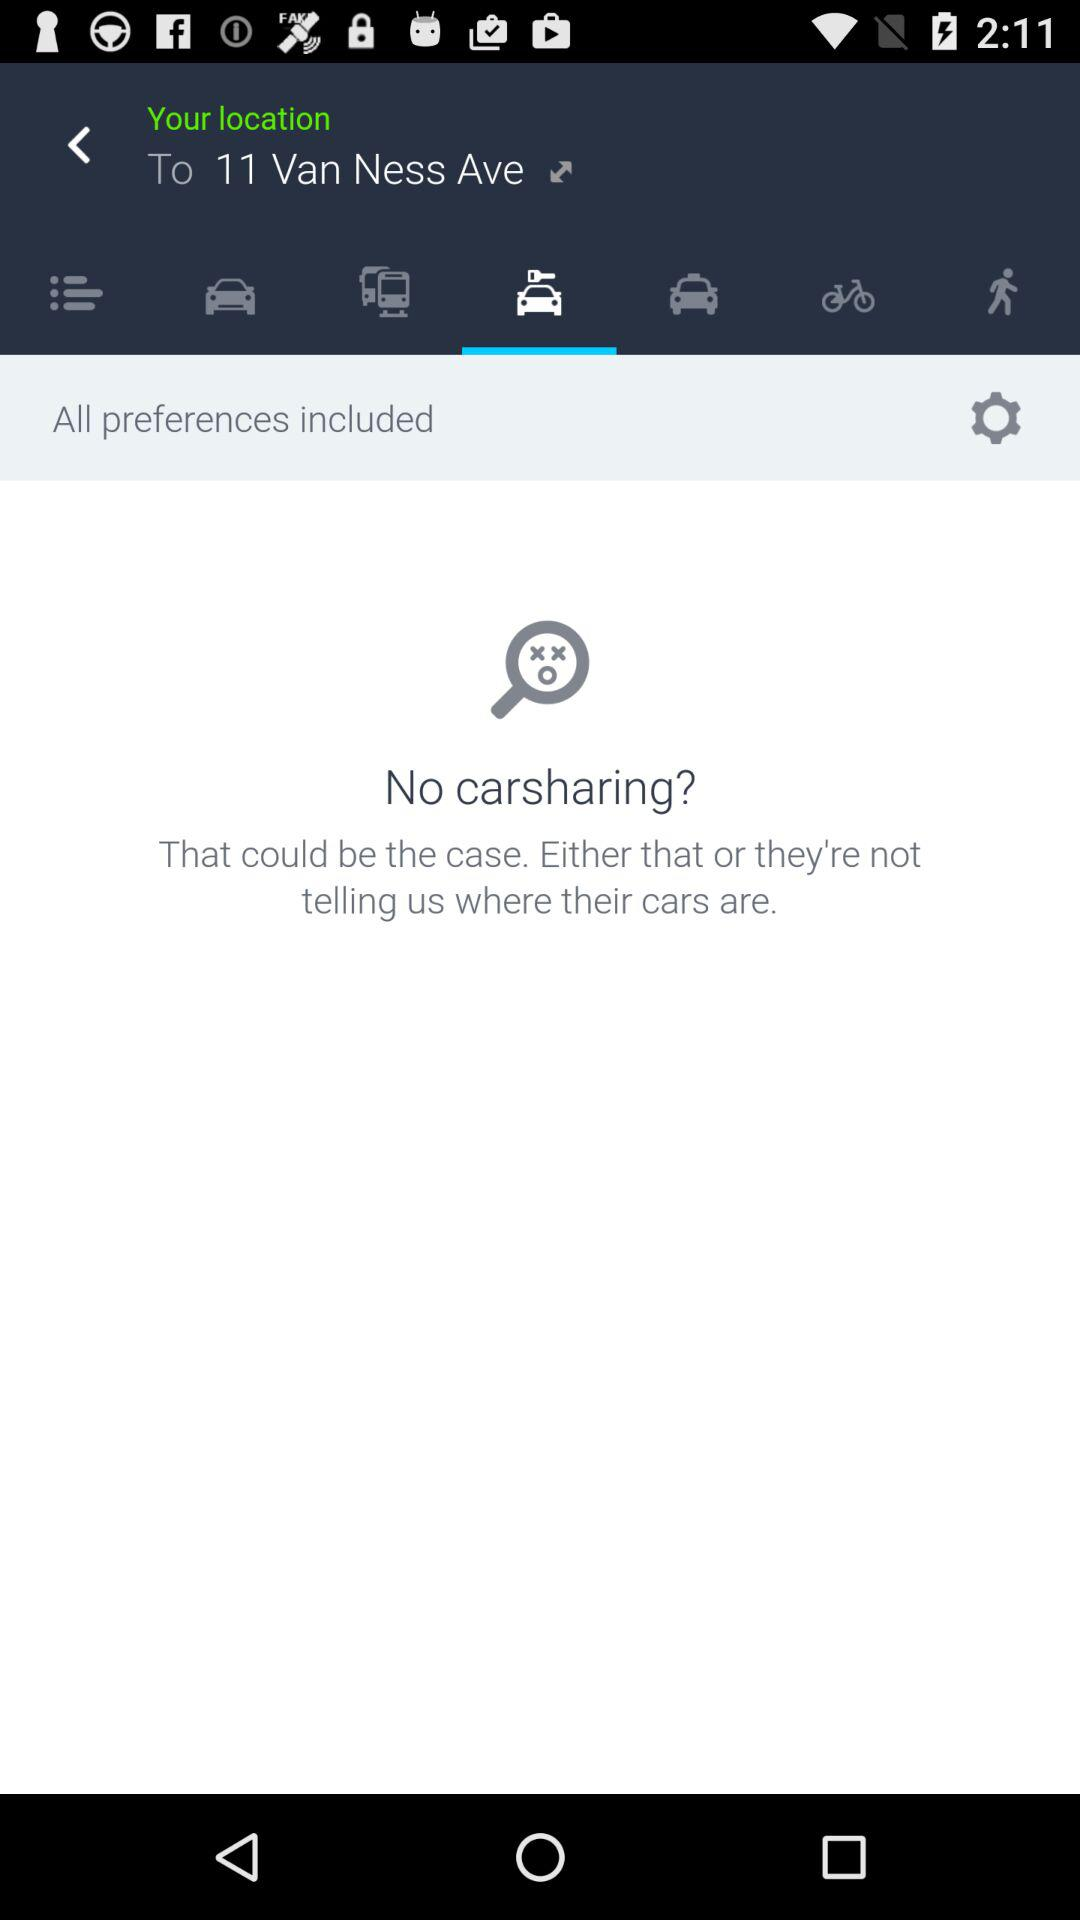How many types of transportation are available?
Answer the question using a single word or phrase. 6 